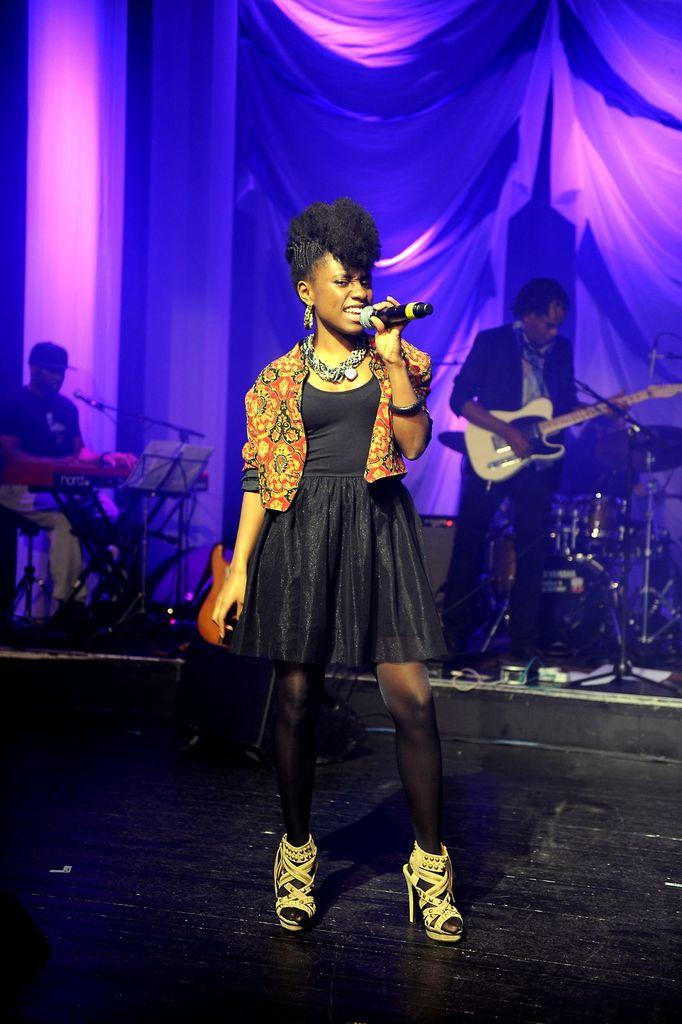What object can be seen in the image that is made of fabric? There is a cloth in the image. What is the woman in the image doing? The woman is singing in the image. What is the woman holding while singing? The woman is holding a microphone. What is the man in the image doing? The man is holding a guitar. What type of advertisement is being displayed on the cloth in the image? There is no advertisement present on the cloth in the image; it is simply a piece of fabric. How many eyes can be seen on the machine in the image? There is no machine present in the image, so it is not possible to determine the number of eyes on it. 